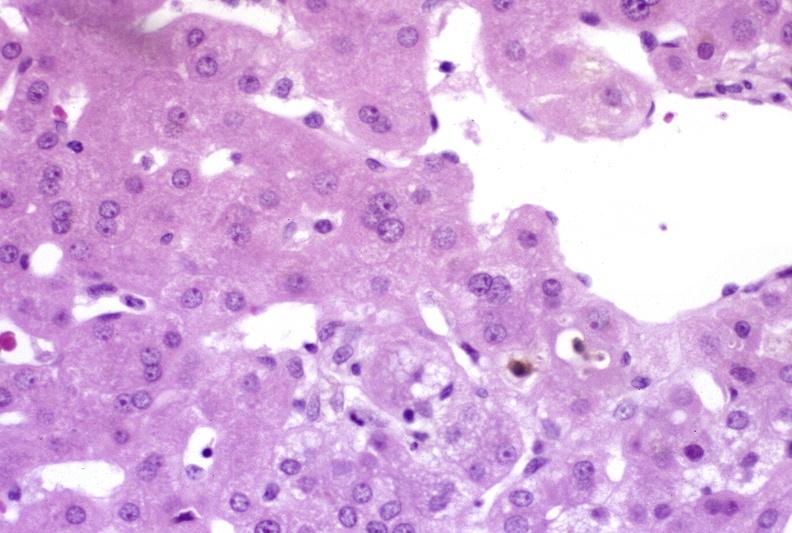does this image show ductopenia?
Answer the question using a single word or phrase. Yes 